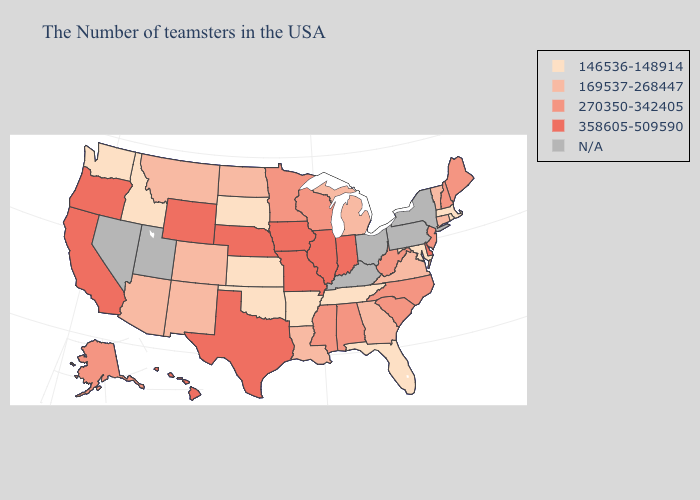How many symbols are there in the legend?
Give a very brief answer. 5. Among the states that border Florida , does Alabama have the lowest value?
Write a very short answer. No. Does Minnesota have the lowest value in the MidWest?
Give a very brief answer. No. What is the value of Tennessee?
Give a very brief answer. 146536-148914. Does Arizona have the highest value in the West?
Answer briefly. No. What is the highest value in the Northeast ?
Write a very short answer. 270350-342405. Among the states that border Wyoming , does Nebraska have the highest value?
Keep it brief. Yes. Which states hav the highest value in the MidWest?
Answer briefly. Indiana, Illinois, Missouri, Iowa, Nebraska. What is the value of Pennsylvania?
Keep it brief. N/A. What is the value of Georgia?
Write a very short answer. 169537-268447. What is the highest value in the USA?
Short answer required. 358605-509590. What is the value of Texas?
Answer briefly. 358605-509590. What is the value of Georgia?
Quick response, please. 169537-268447. 